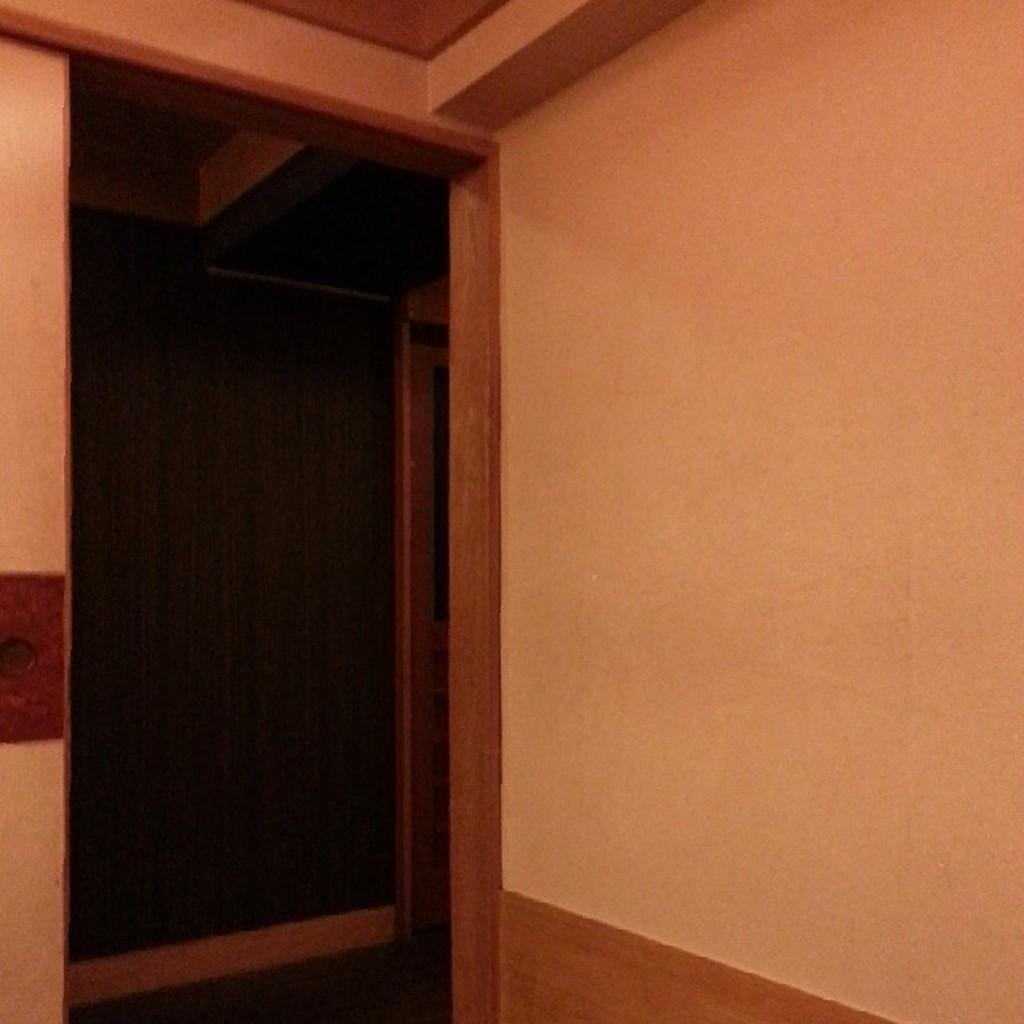What is the setting of the image? The image shows the inside view of a room. Can you describe any specific features of the room? There is a door in the front of the room. What color is the vein visible on the wall in the image? There is no vein visible on the wall in the image. 